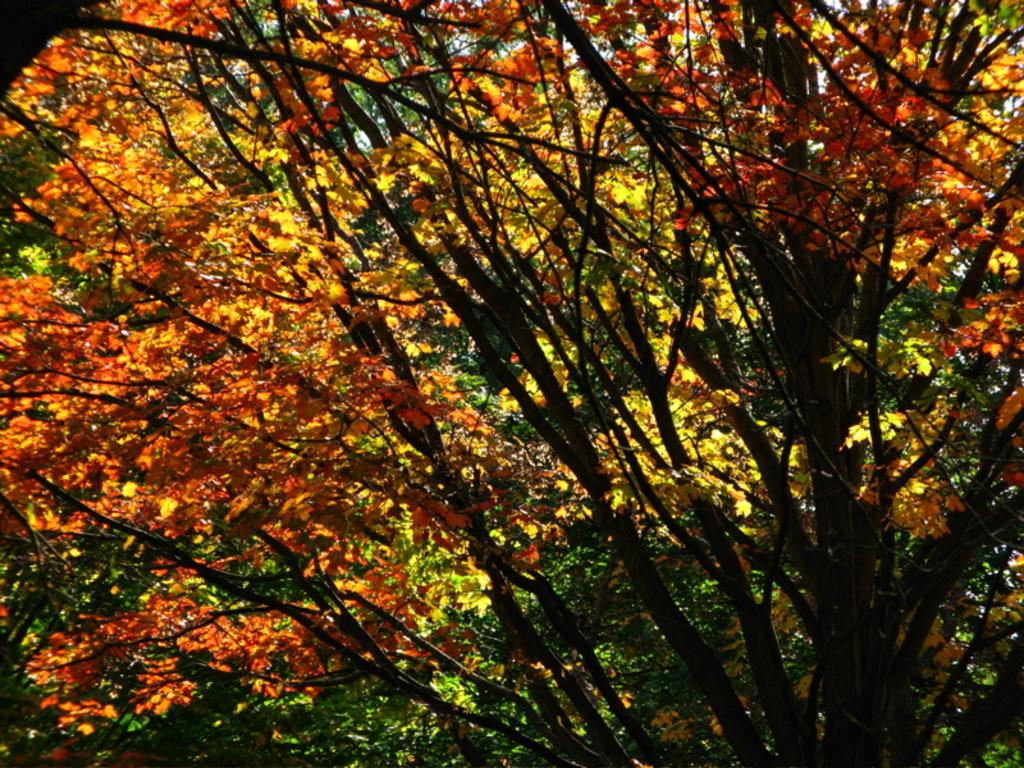What type of plant can be seen in the image? There is a tree in the image. What is the condition of the tree's foliage? The tree has leaves. Where is the mine located in the image? There is no mine present in the image; it features a tree with leaves. What type of meat can be seen hanging from the tree in the image? There is no meat present in the image; it features a tree with leaves. 